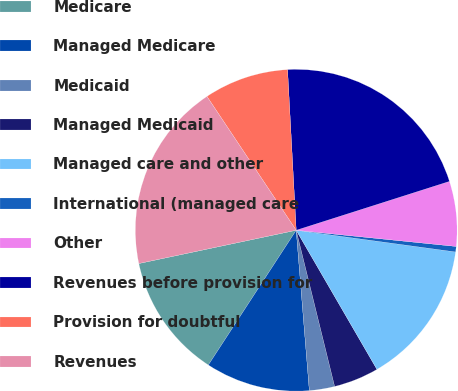Convert chart. <chart><loc_0><loc_0><loc_500><loc_500><pie_chart><fcel>Medicare<fcel>Managed Medicare<fcel>Medicaid<fcel>Managed Medicaid<fcel>Managed care and other<fcel>International (managed care<fcel>Other<fcel>Revenues before provision for<fcel>Provision for doubtful<fcel>Revenues<nl><fcel>12.49%<fcel>10.5%<fcel>2.54%<fcel>4.53%<fcel>14.48%<fcel>0.55%<fcel>6.52%<fcel>20.95%<fcel>8.51%<fcel>18.96%<nl></chart> 